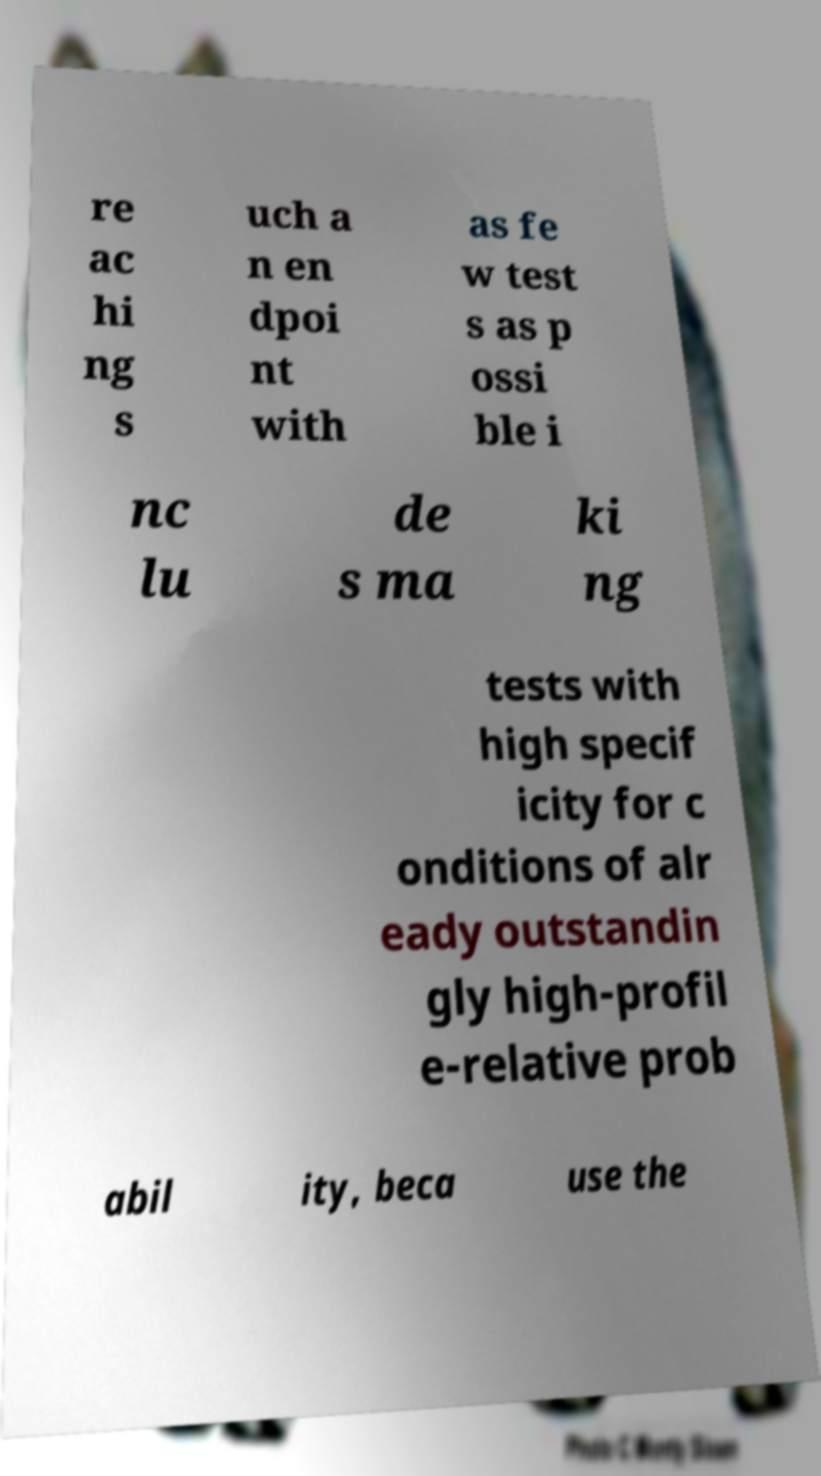There's text embedded in this image that I need extracted. Can you transcribe it verbatim? re ac hi ng s uch a n en dpoi nt with as fe w test s as p ossi ble i nc lu de s ma ki ng tests with high specif icity for c onditions of alr eady outstandin gly high-profil e-relative prob abil ity, beca use the 